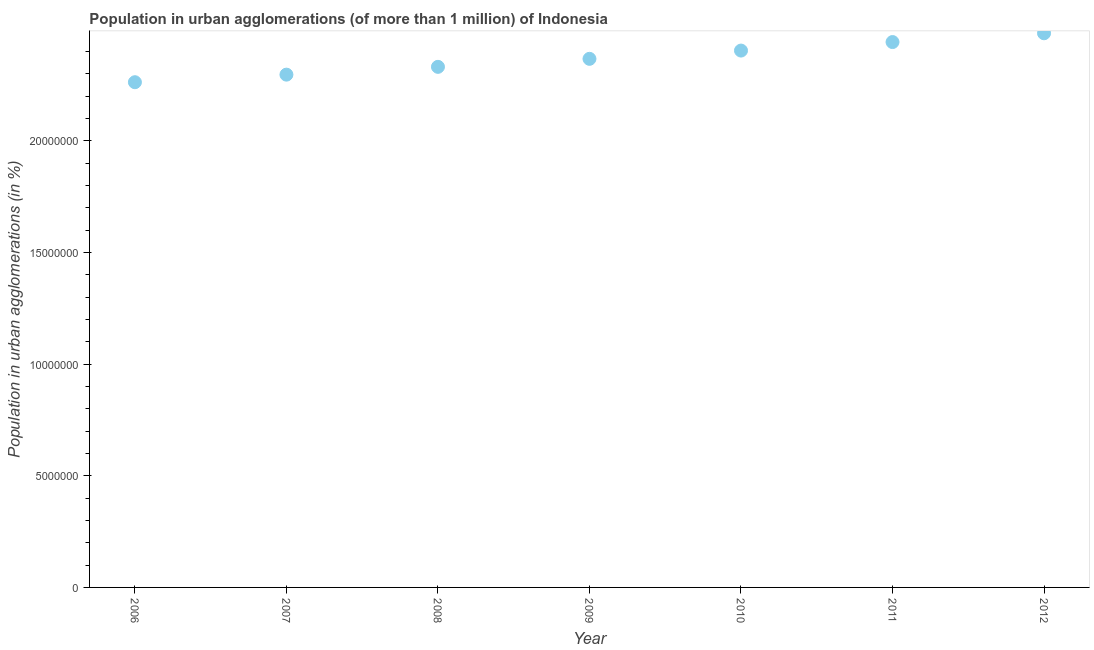What is the population in urban agglomerations in 2008?
Make the answer very short. 2.33e+07. Across all years, what is the maximum population in urban agglomerations?
Make the answer very short. 2.48e+07. Across all years, what is the minimum population in urban agglomerations?
Offer a terse response. 2.26e+07. In which year was the population in urban agglomerations maximum?
Make the answer very short. 2012. In which year was the population in urban agglomerations minimum?
Make the answer very short. 2006. What is the sum of the population in urban agglomerations?
Give a very brief answer. 1.66e+08. What is the difference between the population in urban agglomerations in 2007 and 2008?
Your response must be concise. -3.49e+05. What is the average population in urban agglomerations per year?
Your answer should be compact. 2.37e+07. What is the median population in urban agglomerations?
Give a very brief answer. 2.37e+07. What is the ratio of the population in urban agglomerations in 2006 to that in 2012?
Offer a terse response. 0.91. Is the population in urban agglomerations in 2007 less than that in 2009?
Make the answer very short. Yes. Is the difference between the population in urban agglomerations in 2009 and 2012 greater than the difference between any two years?
Offer a very short reply. No. What is the difference between the highest and the second highest population in urban agglomerations?
Give a very brief answer. 3.93e+05. Is the sum of the population in urban agglomerations in 2007 and 2011 greater than the maximum population in urban agglomerations across all years?
Offer a very short reply. Yes. What is the difference between the highest and the lowest population in urban agglomerations?
Provide a short and direct response. 2.19e+06. How many dotlines are there?
Your answer should be compact. 1. What is the difference between two consecutive major ticks on the Y-axis?
Make the answer very short. 5.00e+06. Does the graph contain any zero values?
Give a very brief answer. No. What is the title of the graph?
Keep it short and to the point. Population in urban agglomerations (of more than 1 million) of Indonesia. What is the label or title of the Y-axis?
Provide a succinct answer. Population in urban agglomerations (in %). What is the Population in urban agglomerations (in %) in 2006?
Provide a succinct answer. 2.26e+07. What is the Population in urban agglomerations (in %) in 2007?
Your response must be concise. 2.30e+07. What is the Population in urban agglomerations (in %) in 2008?
Your answer should be very brief. 2.33e+07. What is the Population in urban agglomerations (in %) in 2009?
Ensure brevity in your answer.  2.37e+07. What is the Population in urban agglomerations (in %) in 2010?
Offer a terse response. 2.40e+07. What is the Population in urban agglomerations (in %) in 2011?
Provide a short and direct response. 2.44e+07. What is the Population in urban agglomerations (in %) in 2012?
Offer a very short reply. 2.48e+07. What is the difference between the Population in urban agglomerations (in %) in 2006 and 2007?
Give a very brief answer. -3.39e+05. What is the difference between the Population in urban agglomerations (in %) in 2006 and 2008?
Make the answer very short. -6.88e+05. What is the difference between the Population in urban agglomerations (in %) in 2006 and 2009?
Keep it short and to the point. -1.05e+06. What is the difference between the Population in urban agglomerations (in %) in 2006 and 2010?
Your answer should be very brief. -1.42e+06. What is the difference between the Population in urban agglomerations (in %) in 2006 and 2011?
Provide a short and direct response. -1.80e+06. What is the difference between the Population in urban agglomerations (in %) in 2006 and 2012?
Your response must be concise. -2.19e+06. What is the difference between the Population in urban agglomerations (in %) in 2007 and 2008?
Ensure brevity in your answer.  -3.49e+05. What is the difference between the Population in urban agglomerations (in %) in 2007 and 2009?
Offer a very short reply. -7.08e+05. What is the difference between the Population in urban agglomerations (in %) in 2007 and 2010?
Your response must be concise. -1.08e+06. What is the difference between the Population in urban agglomerations (in %) in 2007 and 2011?
Your response must be concise. -1.46e+06. What is the difference between the Population in urban agglomerations (in %) in 2007 and 2012?
Make the answer very short. -1.85e+06. What is the difference between the Population in urban agglomerations (in %) in 2008 and 2009?
Provide a succinct answer. -3.59e+05. What is the difference between the Population in urban agglomerations (in %) in 2008 and 2010?
Your response must be concise. -7.28e+05. What is the difference between the Population in urban agglomerations (in %) in 2008 and 2011?
Make the answer very short. -1.11e+06. What is the difference between the Population in urban agglomerations (in %) in 2008 and 2012?
Your answer should be compact. -1.50e+06. What is the difference between the Population in urban agglomerations (in %) in 2009 and 2010?
Offer a terse response. -3.70e+05. What is the difference between the Population in urban agglomerations (in %) in 2009 and 2011?
Provide a short and direct response. -7.51e+05. What is the difference between the Population in urban agglomerations (in %) in 2009 and 2012?
Your response must be concise. -1.14e+06. What is the difference between the Population in urban agglomerations (in %) in 2010 and 2011?
Keep it short and to the point. -3.81e+05. What is the difference between the Population in urban agglomerations (in %) in 2010 and 2012?
Keep it short and to the point. -7.75e+05. What is the difference between the Population in urban agglomerations (in %) in 2011 and 2012?
Your answer should be very brief. -3.93e+05. What is the ratio of the Population in urban agglomerations (in %) in 2006 to that in 2008?
Your response must be concise. 0.97. What is the ratio of the Population in urban agglomerations (in %) in 2006 to that in 2009?
Provide a short and direct response. 0.96. What is the ratio of the Population in urban agglomerations (in %) in 2006 to that in 2010?
Offer a terse response. 0.94. What is the ratio of the Population in urban agglomerations (in %) in 2006 to that in 2011?
Offer a terse response. 0.93. What is the ratio of the Population in urban agglomerations (in %) in 2006 to that in 2012?
Keep it short and to the point. 0.91. What is the ratio of the Population in urban agglomerations (in %) in 2007 to that in 2008?
Keep it short and to the point. 0.98. What is the ratio of the Population in urban agglomerations (in %) in 2007 to that in 2010?
Your answer should be very brief. 0.95. What is the ratio of the Population in urban agglomerations (in %) in 2007 to that in 2011?
Offer a very short reply. 0.94. What is the ratio of the Population in urban agglomerations (in %) in 2007 to that in 2012?
Offer a very short reply. 0.93. What is the ratio of the Population in urban agglomerations (in %) in 2008 to that in 2011?
Ensure brevity in your answer.  0.95. What is the ratio of the Population in urban agglomerations (in %) in 2008 to that in 2012?
Offer a very short reply. 0.94. What is the ratio of the Population in urban agglomerations (in %) in 2009 to that in 2011?
Give a very brief answer. 0.97. What is the ratio of the Population in urban agglomerations (in %) in 2009 to that in 2012?
Provide a short and direct response. 0.95. 